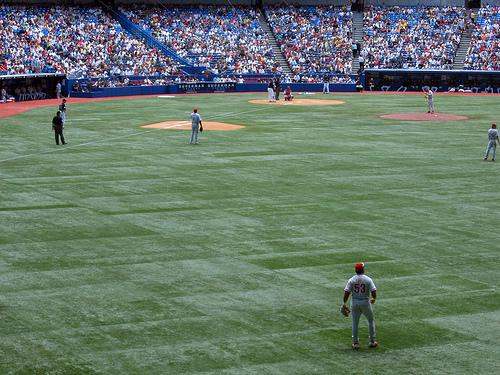Question: where was this picture taken?
Choices:
A. A rodeo arena.
B. A baseball stadium.
C. A ski slope.
D. A swimming pool.
Answer with the letter. Answer: B Question: what game is being played in this picture?
Choices:
A. Basketball.
B. Baseball.
C. Hockey.
D. Volleyball.
Answer with the letter. Answer: B Question: who is wearing the number 53?
Choices:
A. The skier.
B. The runner.
C. A girl in a soccer uniform.
D. A man in a red hat.
Answer with the letter. Answer: D Question: what color are the seats?
Choices:
A. Red.
B. Brown.
C. Black.
D. Blue.
Answer with the letter. Answer: D 